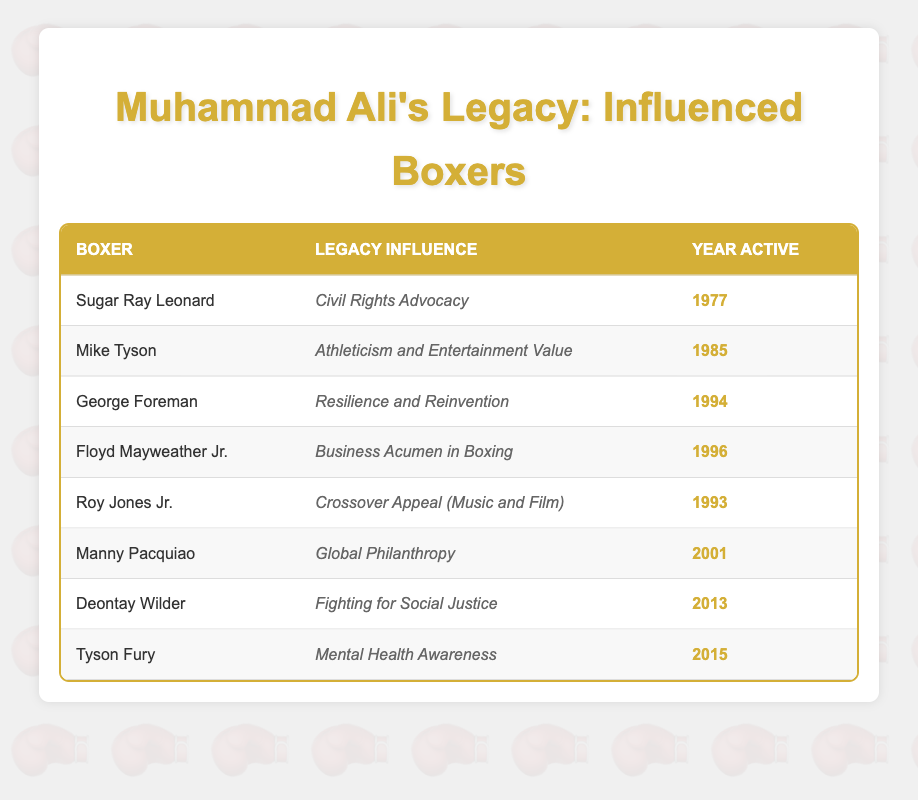What is the Legacy Influence of Sugar Ray Leonard? Sugar Ray Leonard's Legacy Influence is listed in the table as "Civil Rights Advocacy." This can be directly found under the "Legacy Influence" column in the row corresponding to Sugar Ray Leonard.
Answer: Civil Rights Advocacy Which boxer is known for their influence on Global Philanthropy? The table indicates that Manny Pacquiao is the boxer associated with "Global Philanthropy" in the "Legacy Influence" column. This information can be retrieved from Manny Pacquiao's row in the table.
Answer: Manny Pacquiao How many boxers were active in the 1990s? To find the number of boxers active in the 1990s, we count the entries for the years from 1990 to 1999. In the table, the boxers active in this time period are George Foreman (1994), Floyd Mayweather Jr. (1996), and Roy Jones Jr. (1993)—totaling to three.
Answer: 3 Does Tyson Fury influence Mental Health Awareness? The table shows that Tyson Fury's Legacy Influence is specifically "Mental Health Awareness," which answers the question affirmatively. This can be confirmed by checking the corresponding entry for Tyson Fury.
Answer: Yes Which boxer's Legacy Influence involves Resilience and Reinvention, and what year were they active? George Foreman is noted for his influence on "Resilience and Reinvention." According to the table, he was active in the year 1994. Therefore, we can find both details in one row of the table.
Answer: George Foreman, 1994 What is the average year of activity for the boxers listed in the table? To calculate the average year of activity, we sum all the years (1977 + 1985 + 1994 + 1996 + 1993 + 2001 + 2013 + 2015 = 1584) and divide by the number of boxers (8). This gives us an average year of 1984.5, but we round to the nearest whole year for practical relevance, which is 1985.
Answer: 1985 Is there a boxer who has a Legacy Influence related to Athleticism and Entertainment Value? According to the table, Mike Tyson is the boxer whose Legacy Influence is categorized as "Athleticism and Entertainment Value," which confirms the existence of such a boxer. This can be directly seen in his row.
Answer: Yes What is the Legacy Influence of the boxer who was active in 2015? Tyson Fury, who was active in 2015, is listed in the table and his Legacy Influence is "Mental Health Awareness." This is explicitly stated in the corresponding row.
Answer: Mental Health Awareness 